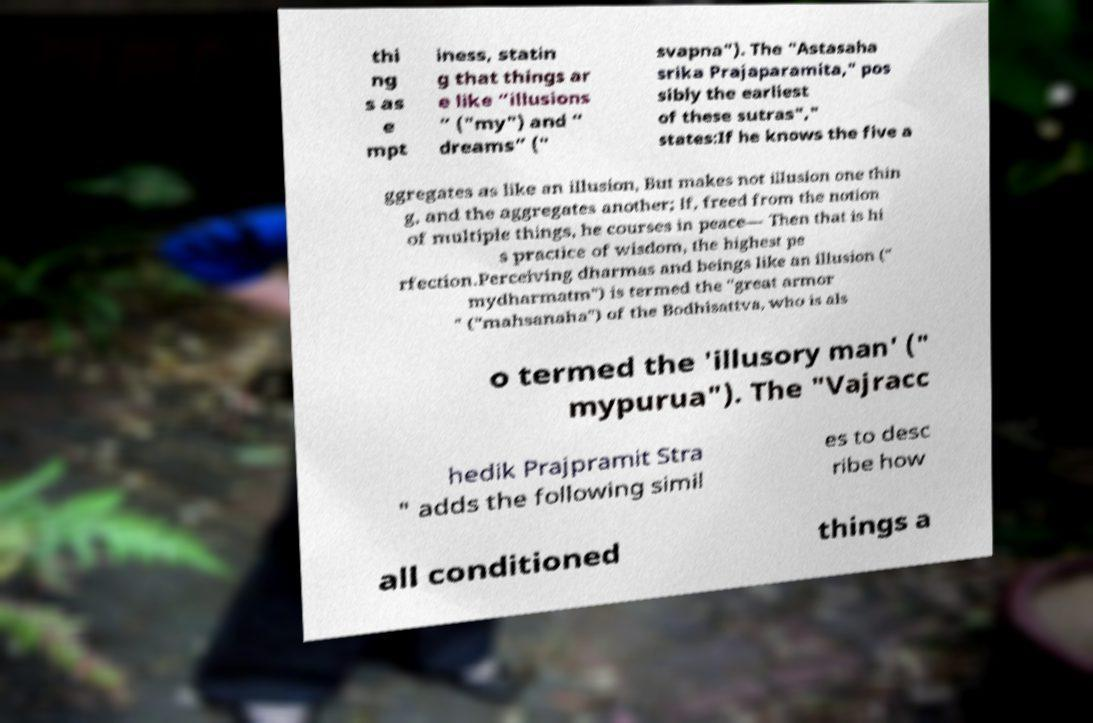Could you assist in decoding the text presented in this image and type it out clearly? thi ng s as e mpt iness, statin g that things ar e like “illusions ” ("my") and “ dreams” (" svapna"). The "Astasaha srika Prajaparamita," pos sibly the earliest of these sutras"," states:If he knows the five a ggregates as like an illusion, But makes not illusion one thin g, and the aggregates another; If, freed from the notion of multiple things, he courses in peace— Then that is hi s practice of wisdom, the highest pe rfection.Perceiving dharmas and beings like an illusion (" mydharmatm") is termed the "great armor " ("mahsanaha") of the Bodhisattva, who is als o termed the 'illusory man' (" mypurua"). The "Vajracc hedik Prajpramit Stra " adds the following simil es to desc ribe how all conditioned things a 